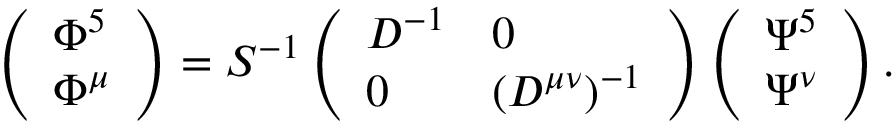Convert formula to latex. <formula><loc_0><loc_0><loc_500><loc_500>\left ( \begin{array} { l } { { \Phi ^ { 5 } } } \\ { { \Phi ^ { \mu } } } \end{array} \right ) = S ^ { - 1 } \left ( \begin{array} { l l } { { D ^ { - 1 } } } & { 0 } \\ { 0 } & { { ( D ^ { \mu \nu } ) ^ { - 1 } } } \end{array} \right ) \left ( \begin{array} { l } { { \Psi ^ { 5 } } } \\ { { \Psi ^ { \nu } } } \end{array} \right ) .</formula> 